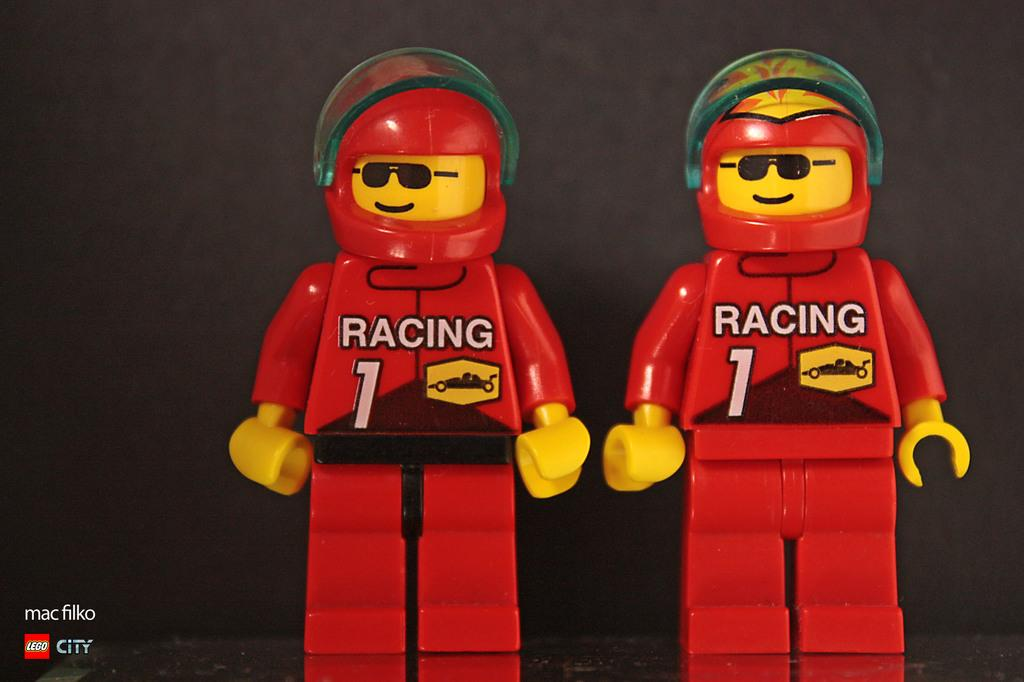What type of objects can be seen in the image? There are toys in the image. What type of plastic material is used to make the plough in the image? There is no plough present in the image; it only features toys. What type of basin can be seen holding water in the image? There is no basin or water present in the image; it only features toys. 